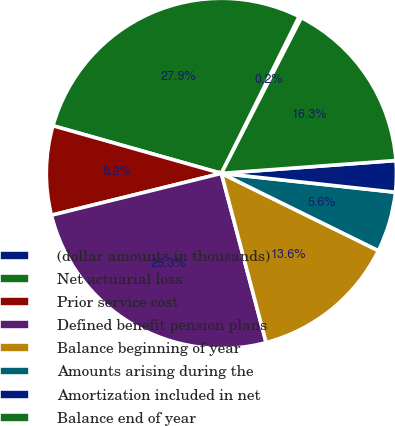<chart> <loc_0><loc_0><loc_500><loc_500><pie_chart><fcel>(dollar amounts in thousands)<fcel>Net actuarial loss<fcel>Prior service cost<fcel>Defined benefit pension plans<fcel>Balance beginning of year<fcel>Amounts arising during the<fcel>Amortization included in net<fcel>Balance end of year<nl><fcel>0.23%<fcel>27.94%<fcel>8.23%<fcel>25.27%<fcel>13.61%<fcel>5.56%<fcel>2.89%<fcel>16.28%<nl></chart> 